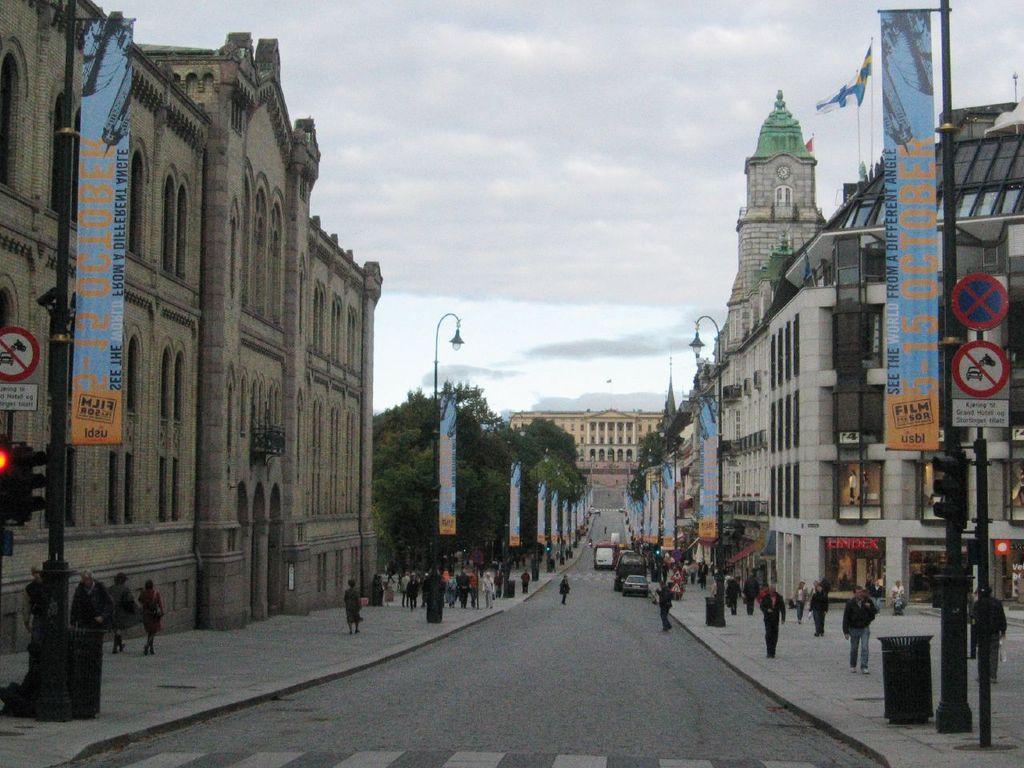Please provide a concise description of this image. In this picture I can see some vehicles are on the roadside few people are walking and also I can see some buildings, banners, trees and some boards. 